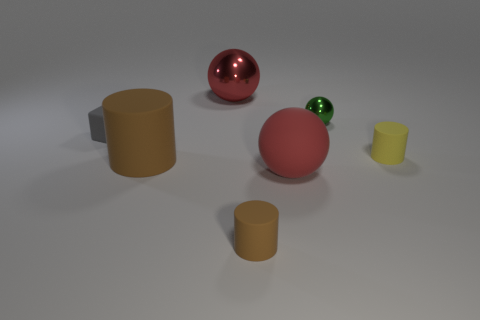There is a large rubber sphere; does it have the same color as the tiny rubber object that is behind the yellow rubber cylinder?
Keep it short and to the point. No. What number of red objects are either small cubes or big matte spheres?
Your answer should be compact. 1. Are there an equal number of red matte balls behind the small metal thing and small balls?
Ensure brevity in your answer.  No. Is there anything else that has the same size as the block?
Your answer should be compact. Yes. What color is the other small rubber object that is the same shape as the small brown thing?
Your answer should be very brief. Yellow. How many big red metal objects are the same shape as the tiny green thing?
Offer a very short reply. 1. What material is the other ball that is the same color as the big rubber ball?
Ensure brevity in your answer.  Metal. What number of small yellow cylinders are there?
Offer a very short reply. 1. Are there any green things made of the same material as the small yellow cylinder?
Give a very brief answer. No. The thing that is the same color as the rubber sphere is what size?
Keep it short and to the point. Large. 